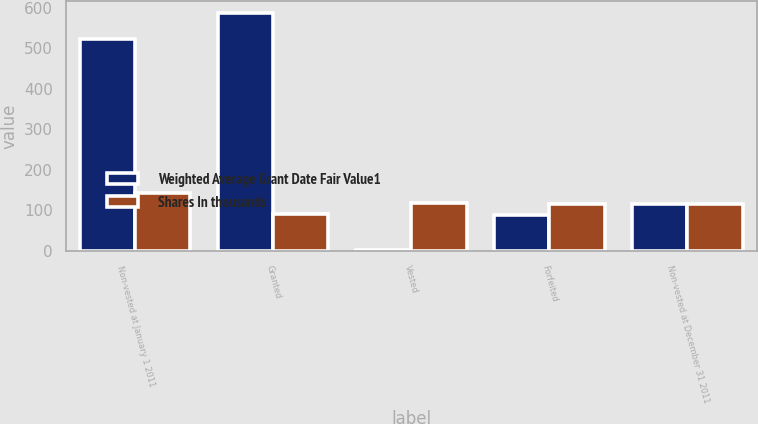Convert chart to OTSL. <chart><loc_0><loc_0><loc_500><loc_500><stacked_bar_chart><ecel><fcel>Non-vested at January 1 2011<fcel>Granted<fcel>Vested<fcel>Forfeited<fcel>Non-vested at December 31 2011<nl><fcel>Weighted Average Grant Date Fair Value1<fcel>523<fcel>586<fcel>2<fcel>88<fcel>115.67<nl><fcel>Shares In thousands<fcel>141.86<fcel>91.29<fcel>118.31<fcel>115.67<fcel>115.1<nl></chart> 